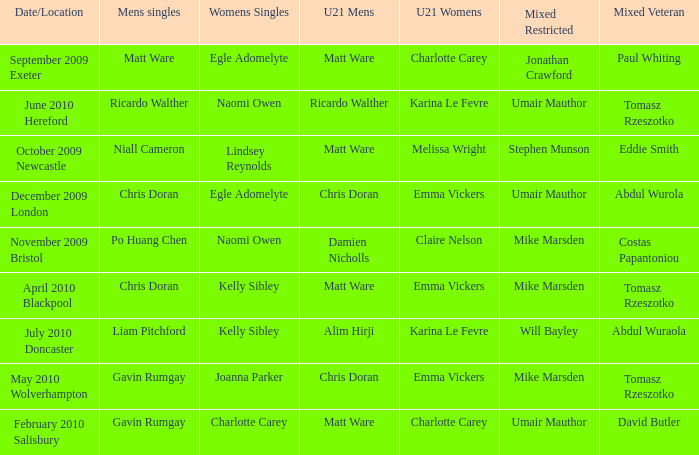Who was the U21 Mens winner when Mike Marsden was the mixed restricted winner and Claire Nelson was the U21 Womens winner?  Damien Nicholls. Parse the full table. {'header': ['Date/Location', 'Mens singles', 'Womens Singles', 'U21 Mens', 'U21 Womens', 'Mixed Restricted', 'Mixed Veteran'], 'rows': [['September 2009 Exeter', 'Matt Ware', 'Egle Adomelyte', 'Matt Ware', 'Charlotte Carey', 'Jonathan Crawford', 'Paul Whiting'], ['June 2010 Hereford', 'Ricardo Walther', 'Naomi Owen', 'Ricardo Walther', 'Karina Le Fevre', 'Umair Mauthor', 'Tomasz Rzeszotko'], ['October 2009 Newcastle', 'Niall Cameron', 'Lindsey Reynolds', 'Matt Ware', 'Melissa Wright', 'Stephen Munson', 'Eddie Smith'], ['December 2009 London', 'Chris Doran', 'Egle Adomelyte', 'Chris Doran', 'Emma Vickers', 'Umair Mauthor', 'Abdul Wurola'], ['November 2009 Bristol', 'Po Huang Chen', 'Naomi Owen', 'Damien Nicholls', 'Claire Nelson', 'Mike Marsden', 'Costas Papantoniou'], ['April 2010 Blackpool', 'Chris Doran', 'Kelly Sibley', 'Matt Ware', 'Emma Vickers', 'Mike Marsden', 'Tomasz Rzeszotko'], ['July 2010 Doncaster', 'Liam Pitchford', 'Kelly Sibley', 'Alim Hirji', 'Karina Le Fevre', 'Will Bayley', 'Abdul Wuraola'], ['May 2010 Wolverhampton', 'Gavin Rumgay', 'Joanna Parker', 'Chris Doran', 'Emma Vickers', 'Mike Marsden', 'Tomasz Rzeszotko'], ['February 2010 Salisbury', 'Gavin Rumgay', 'Charlotte Carey', 'Matt Ware', 'Charlotte Carey', 'Umair Mauthor', 'David Butler']]} 